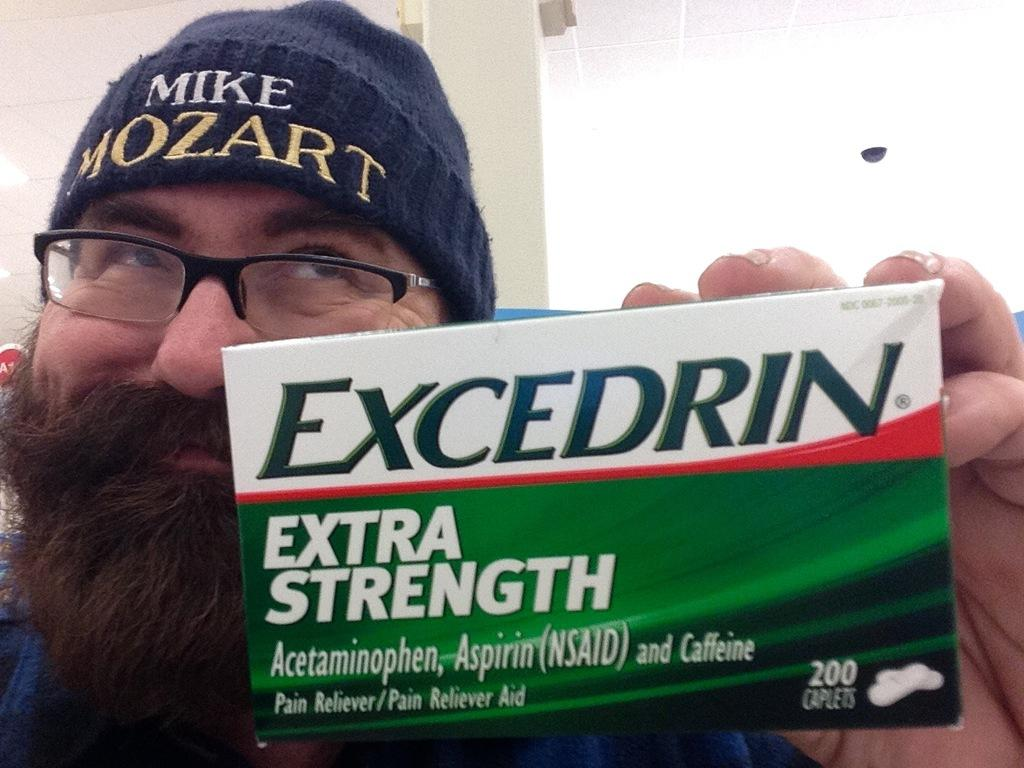What is the main subject of the image? There is a person in the image. What is the person doing in the image? The person is holding something. Can you describe the object being held by the person? There is text written on the object being held. What type of fowl can be seen in the image? There is no fowl present in the image. How is the daughter related to the person in the image? There is no mention of a daughter in the image or the provided facts. 